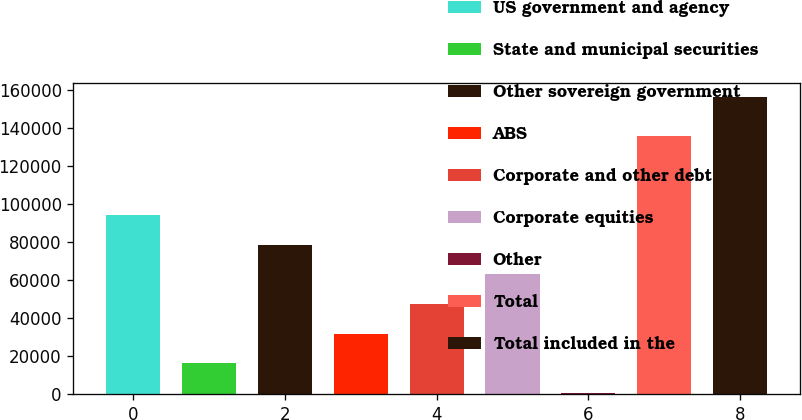<chart> <loc_0><loc_0><loc_500><loc_500><bar_chart><fcel>US government and agency<fcel>State and municipal securities<fcel>Other sovereign government<fcel>ABS<fcel>Corporate and other debt<fcel>Corporate equities<fcel>Other<fcel>Total<fcel>Total included in the<nl><fcel>94013.8<fcel>16402.3<fcel>78491.5<fcel>31924.6<fcel>47446.9<fcel>62969.2<fcel>880<fcel>135561<fcel>156103<nl></chart> 